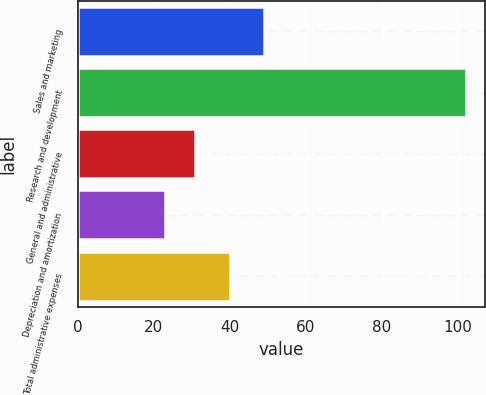Convert chart to OTSL. <chart><loc_0><loc_0><loc_500><loc_500><bar_chart><fcel>Sales and marketing<fcel>Research and development<fcel>General and administrative<fcel>Depreciation and amortization<fcel>Total administrative expenses<nl><fcel>49<fcel>102<fcel>30.9<fcel>23<fcel>40<nl></chart> 